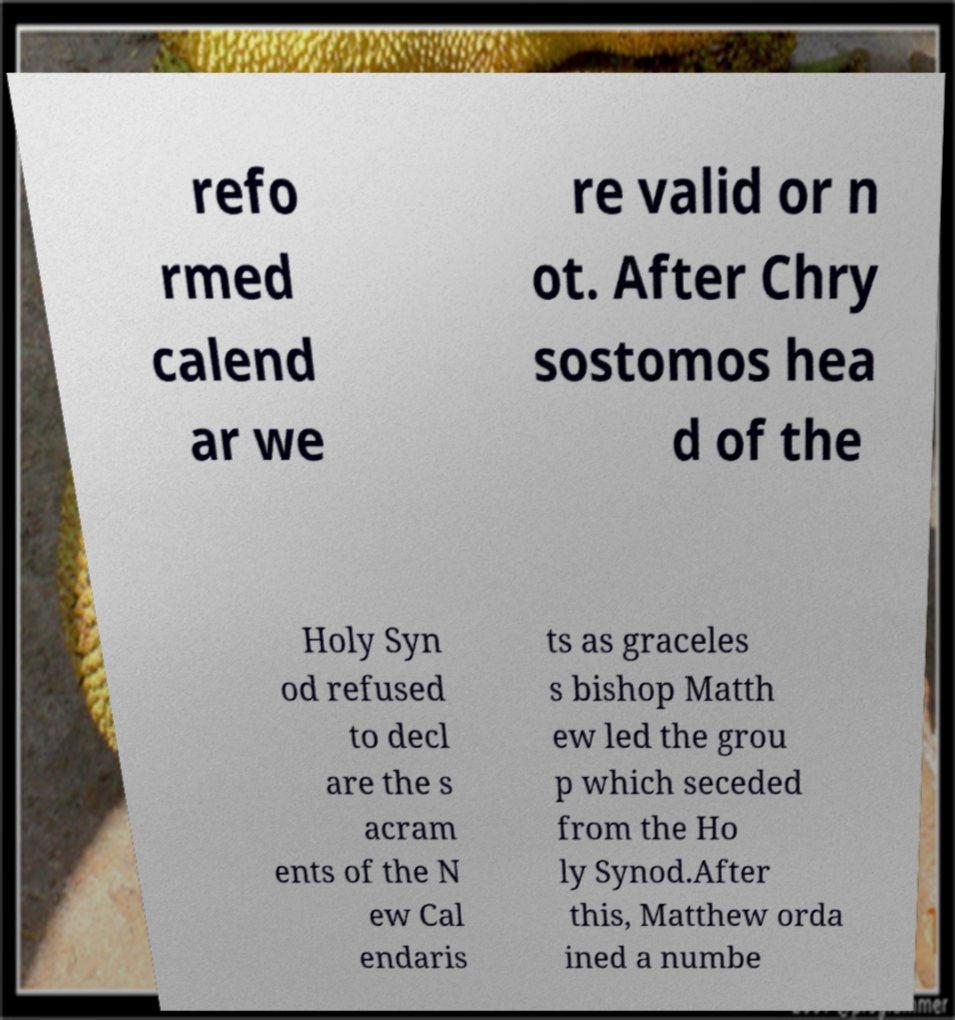Can you read and provide the text displayed in the image?This photo seems to have some interesting text. Can you extract and type it out for me? refo rmed calend ar we re valid or n ot. After Chry sostomos hea d of the Holy Syn od refused to decl are the s acram ents of the N ew Cal endaris ts as graceles s bishop Matth ew led the grou p which seceded from the Ho ly Synod.After this, Matthew orda ined a numbe 